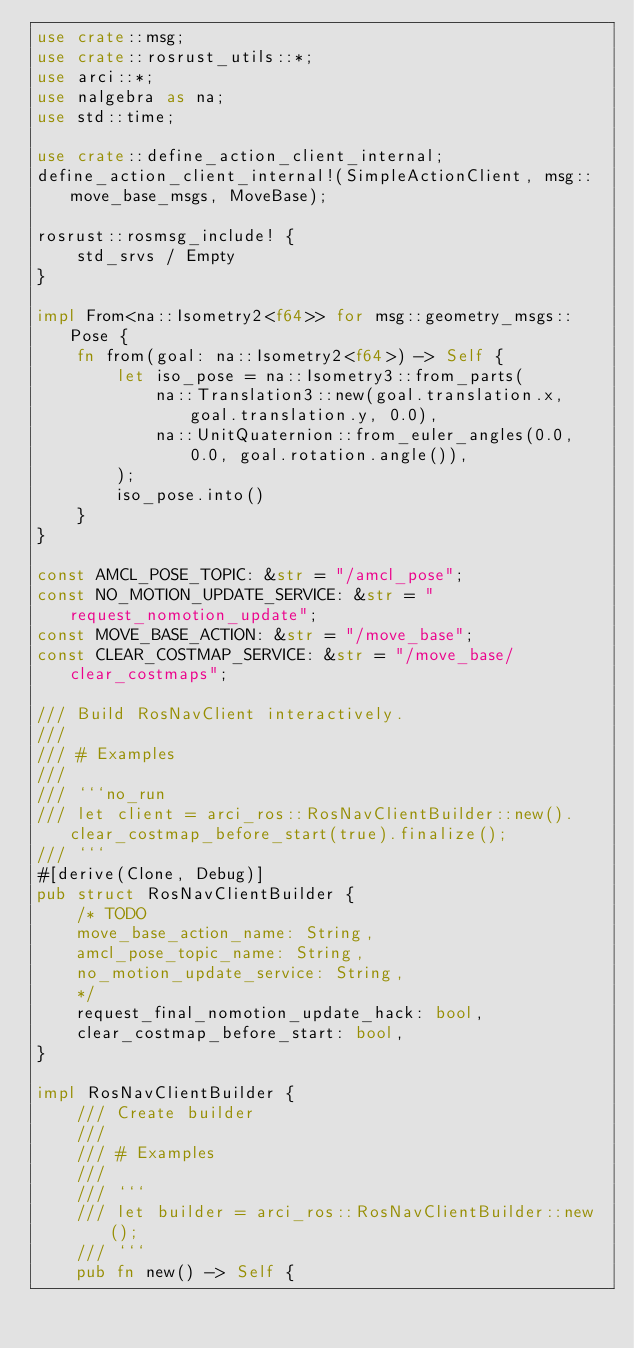Convert code to text. <code><loc_0><loc_0><loc_500><loc_500><_Rust_>use crate::msg;
use crate::rosrust_utils::*;
use arci::*;
use nalgebra as na;
use std::time;

use crate::define_action_client_internal;
define_action_client_internal!(SimpleActionClient, msg::move_base_msgs, MoveBase);

rosrust::rosmsg_include! {
    std_srvs / Empty
}

impl From<na::Isometry2<f64>> for msg::geometry_msgs::Pose {
    fn from(goal: na::Isometry2<f64>) -> Self {
        let iso_pose = na::Isometry3::from_parts(
            na::Translation3::new(goal.translation.x, goal.translation.y, 0.0),
            na::UnitQuaternion::from_euler_angles(0.0, 0.0, goal.rotation.angle()),
        );
        iso_pose.into()
    }
}

const AMCL_POSE_TOPIC: &str = "/amcl_pose";
const NO_MOTION_UPDATE_SERVICE: &str = "request_nomotion_update";
const MOVE_BASE_ACTION: &str = "/move_base";
const CLEAR_COSTMAP_SERVICE: &str = "/move_base/clear_costmaps";

/// Build RosNavClient interactively.
///
/// # Examples
///
/// ```no_run
/// let client = arci_ros::RosNavClientBuilder::new().clear_costmap_before_start(true).finalize();
/// ```
#[derive(Clone, Debug)]
pub struct RosNavClientBuilder {
    /* TODO
    move_base_action_name: String,
    amcl_pose_topic_name: String,
    no_motion_update_service: String,
    */
    request_final_nomotion_update_hack: bool,
    clear_costmap_before_start: bool,
}

impl RosNavClientBuilder {
    /// Create builder
    ///
    /// # Examples
    ///
    /// ```
    /// let builder = arci_ros::RosNavClientBuilder::new();
    /// ```
    pub fn new() -> Self {</code> 